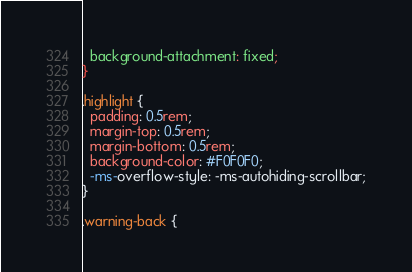<code> <loc_0><loc_0><loc_500><loc_500><_CSS_>  background-attachment: fixed;
}

.highlight {
  padding: 0.5rem;
  margin-top: 0.5rem;
  margin-bottom: 0.5rem;
  background-color: #F0F0F0;
  -ms-overflow-style: -ms-autohiding-scrollbar;
}

.warning-back {</code> 